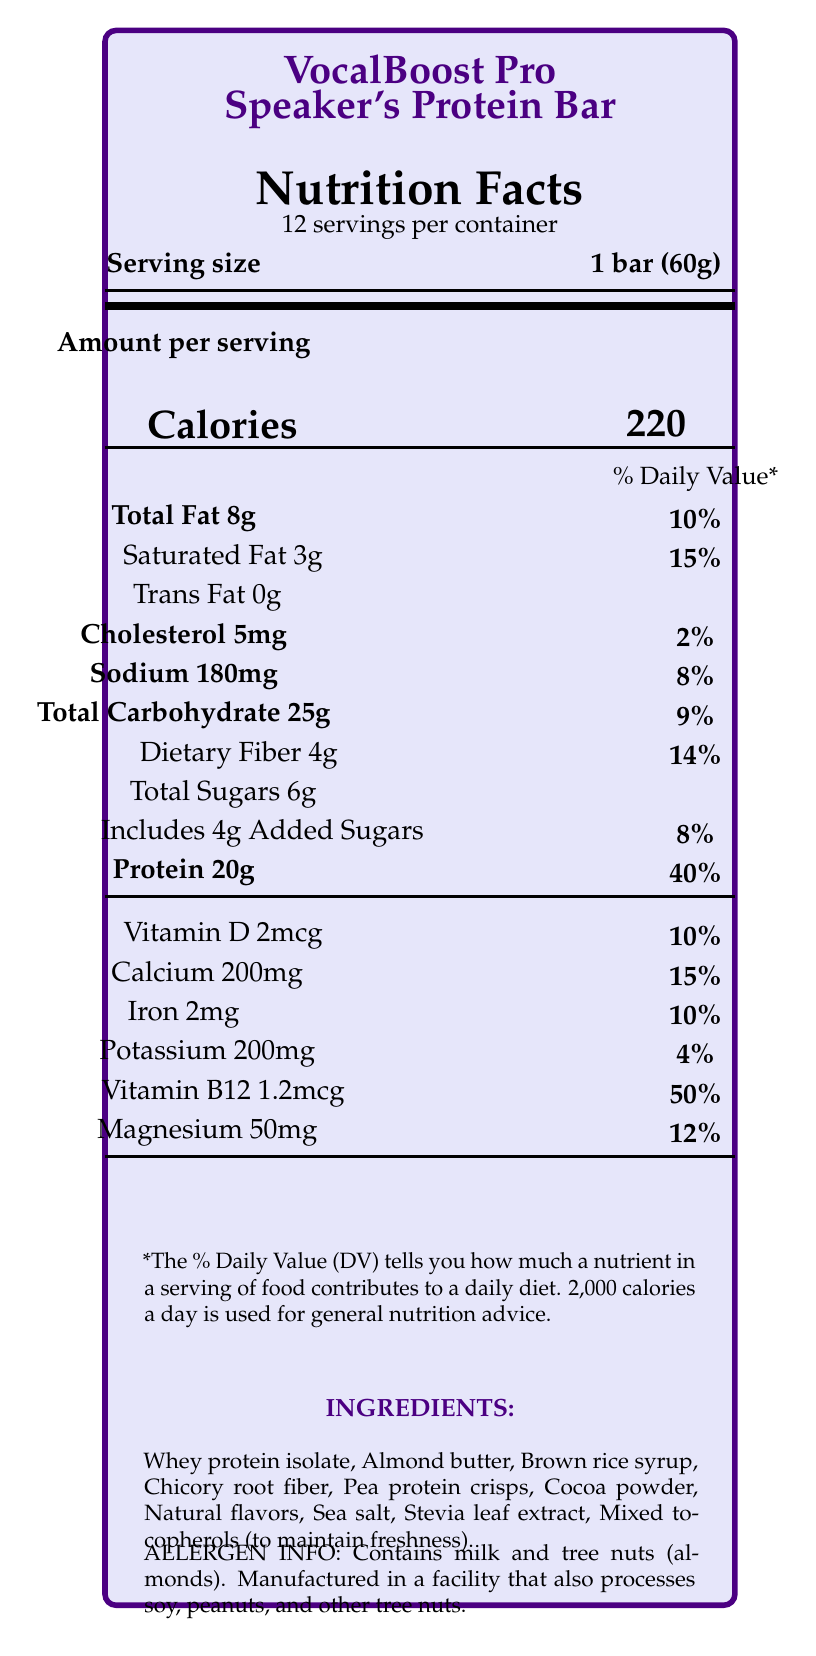what is the serving size of the VocalBoost Pro Speaker's Protein Bar? The serving size is listed as "1 bar (60g)" in the document.
Answer: 1 bar (60g) how many servings are there per container? The document states there are 12 servings per container.
Answer: 12 servings how much protein does each bar provide? The Nutrition Facts list "Protein 20g" per serving.
Answer: 20g what percentage of the daily value of vitamin B12 does each bar provide? The document lists Vitamin B12, showing 50% of the daily value for each bar.
Answer: 50% what are the first two ingredients listed? The first two ingredients listed are Whey protein isolate and Almond butter.
Answer: Whey protein isolate, Almond butter what is the total amount of fat per serving? The Nutrition Facts state "Total Fat 8g".
Answer: 8g what percentage of the daily value of saturated fat is in each serving? A. 5% B. 10% C. 15% D. 20% The document states the saturated fat is 3g, which is 15% of the daily value.
Answer: C which of the following nutrients is not mentioned in the Nutrition Facts? 1. Vitamin C 2. Magnesium 3. Sodium 4. Calcium Vitamin C is not listed in the Nutrition Facts, while Magnesium, Sodium, and Calcium are.
Answer: 1 does the product contain any added sugars? The document lists "Includes 4g Added Sugars".
Answer: Yes does the product contain any allergens? The allergen information states that the product contains milk and tree nuts (almonds).
Answer: Yes summarize the main features and purposes of the VocalBoost Pro Speaker's Protein Bar. The document details the nutritional content, ingredients, key features, and targeted benefits of the VocalBoost Pro Speaker's Protein Bar, emphasizing its formulation for public speakers and media personalities.
Answer: The VocalBoost Pro Speaker's Protein Bar is specifically formulated for public speakers and media personalities. It provides 20g of high-quality protein for sustained energy, is low in sugar to prevent energy crashes, and includes added B12 for vocal cord health. It also contains magnesium to support nerve function and reduce stage fright, along with balanced macronutrients for optimal cognitive performance. what is the total amount of dietary fiber in each bar? The document lists "Dietary Fiber 4g" as part of the Nutrition Facts.
Answer: 4g is the product suitable for people with soy allergies? why? why not? While the product itself does not contain soy, it is manufactured in a facility that processes soy, so there is a risk of cross-contamination.
Answer: Not entirely; Contains milk and tree nuts (almonds). Manufactured in a facility that also processes soy. how much calcium does the product provide per serving? The document states "Calcium 200mg" per serving.
Answer: 200mg how many calories does each bar contain? The document states that each serving has 220 calories.
Answer: 220 calories how does the product help maintain cognitive performance? The key features mention that the bar has balanced macronutrients which help in maintaining cognitive performance.
Answer: Balanced macronutrients for optimal cognitive performance are there any trans fats present in the bar? The document lists "Trans Fat 0g".
Answer: No how much cholesterol is in one serving? The document states there are 5mg of cholesterol per serving.
Answer: 5mg who is the target audience for VocalBoost Pro Speaker's Protein Bar? The marketing claims specify that the bar is formulated specifically for public speakers and media personalities.
Answer: Public speakers and media personalities is the bar high in sugars? The bar contains 6g of total sugars, including 4g of added sugars, which is reasonably low.
Answer: No what form of sweetener is used in the product? The ingredients list includes Stevia leaf extract as a sweetener.
Answer: Stevia leaf extract which feature specifically supports nerve function and reduces stage fright? The key features mention that magnesium in the bar supports nerve function and reduces stage fright.
Answer: Magnesium does this protein bar contain gluten? The document does not provide specific information on whether the product contains gluten.
Answer: Cannot be determined 